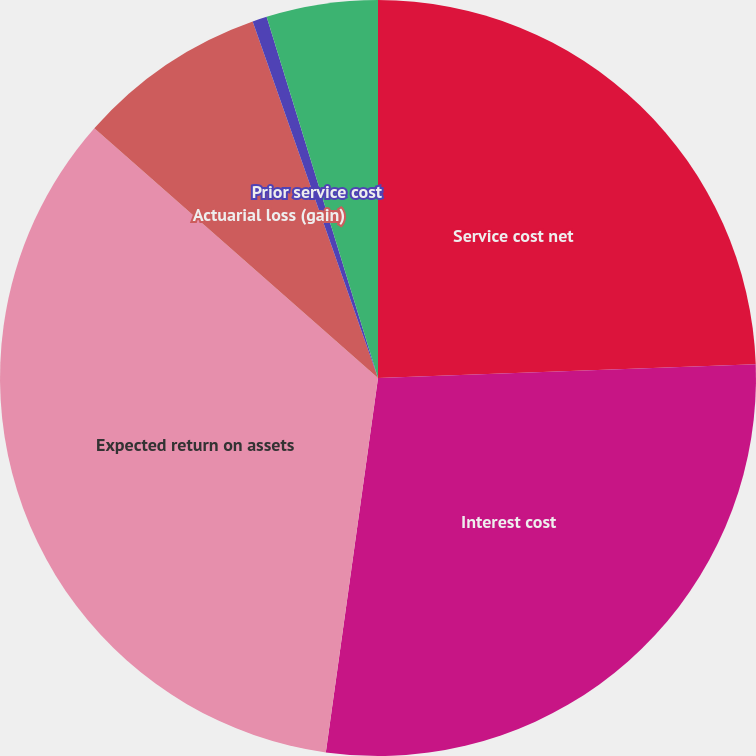Convert chart to OTSL. <chart><loc_0><loc_0><loc_500><loc_500><pie_chart><fcel>Service cost net<fcel>Interest cost<fcel>Expected return on assets<fcel>Actuarial loss (gain)<fcel>Prior service cost<fcel>Weighted-average assumptions<nl><fcel>24.42%<fcel>27.79%<fcel>34.29%<fcel>8.13%<fcel>0.62%<fcel>4.76%<nl></chart> 